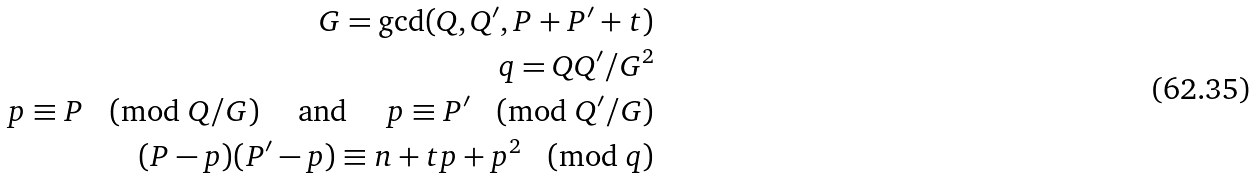<formula> <loc_0><loc_0><loc_500><loc_500>G = \gcd ( Q , Q ^ { \prime } , P + P ^ { \prime } + t ) \\ q = Q Q ^ { \prime } / G ^ { 2 } \\ p \equiv P \pmod { Q / G } \quad \text { and } \quad p \equiv P ^ { \prime } \pmod { Q ^ { \prime } / G } \\ ( P - p ) ( P ^ { \prime } - p ) \equiv n + t p + p ^ { 2 } \pmod { q }</formula> 